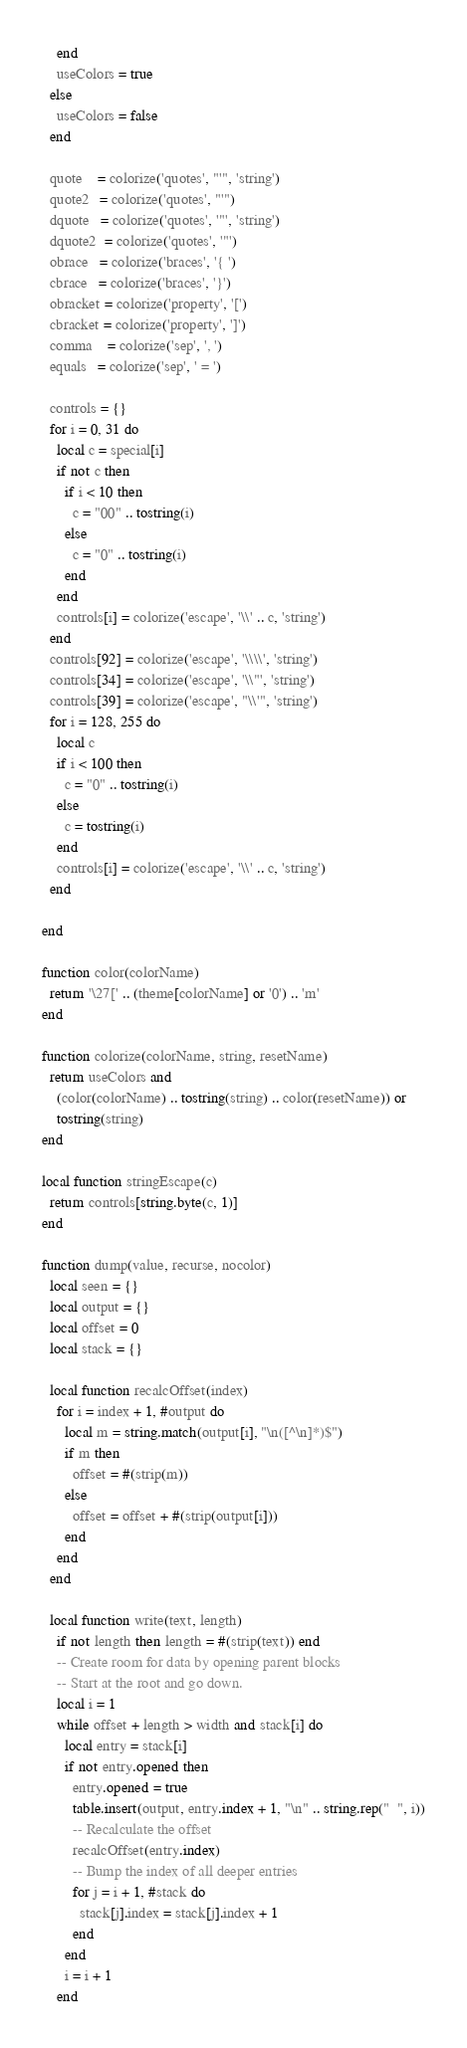<code> <loc_0><loc_0><loc_500><loc_500><_Lua_>    end
    useColors = true
  else
    useColors = false
  end

  quote    = colorize('quotes', "'", 'string')
  quote2   = colorize('quotes', "'")
  dquote   = colorize('quotes', '"', 'string')
  dquote2  = colorize('quotes', '"')
  obrace   = colorize('braces', '{ ')
  cbrace   = colorize('braces', '}')
  obracket = colorize('property', '[')
  cbracket = colorize('property', ']')
  comma    = colorize('sep', ', ')
  equals   = colorize('sep', ' = ')

  controls = {}
  for i = 0, 31 do
    local c = special[i]
    if not c then
      if i < 10 then
        c = "00" .. tostring(i)
      else
        c = "0" .. tostring(i)
      end
    end
    controls[i] = colorize('escape', '\\' .. c, 'string')
  end
  controls[92] = colorize('escape', '\\\\', 'string')
  controls[34] = colorize('escape', '\\"', 'string')
  controls[39] = colorize('escape', "\\'", 'string')
  for i = 128, 255 do
    local c
    if i < 100 then
      c = "0" .. tostring(i)
    else
      c = tostring(i)
    end
    controls[i] = colorize('escape', '\\' .. c, 'string')
  end

end

function color(colorName)
  return '\27[' .. (theme[colorName] or '0') .. 'm'
end

function colorize(colorName, string, resetName)
  return useColors and
    (color(colorName) .. tostring(string) .. color(resetName)) or
    tostring(string)
end

local function stringEscape(c)
  return controls[string.byte(c, 1)]
end

function dump(value, recurse, nocolor)
  local seen = {}
  local output = {}
  local offset = 0
  local stack = {}

  local function recalcOffset(index)
    for i = index + 1, #output do
      local m = string.match(output[i], "\n([^\n]*)$")
      if m then
        offset = #(strip(m))
      else
        offset = offset + #(strip(output[i]))
      end
    end
  end

  local function write(text, length)
    if not length then length = #(strip(text)) end
    -- Create room for data by opening parent blocks
    -- Start at the root and go down.
    local i = 1
    while offset + length > width and stack[i] do
      local entry = stack[i]
      if not entry.opened then
        entry.opened = true
        table.insert(output, entry.index + 1, "\n" .. string.rep("  ", i))
        -- Recalculate the offset
        recalcOffset(entry.index)
        -- Bump the index of all deeper entries
        for j = i + 1, #stack do
          stack[j].index = stack[j].index + 1
        end
      end
      i = i + 1
    end</code> 